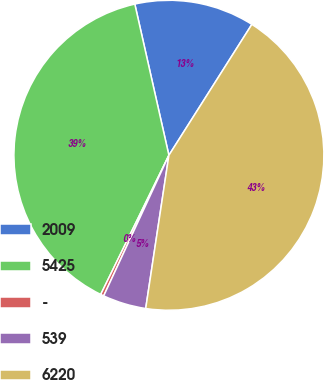Convert chart to OTSL. <chart><loc_0><loc_0><loc_500><loc_500><pie_chart><fcel>2009<fcel>5425<fcel>-<fcel>539<fcel>6220<nl><fcel>12.52%<fcel>39.22%<fcel>0.34%<fcel>4.52%<fcel>43.4%<nl></chart> 